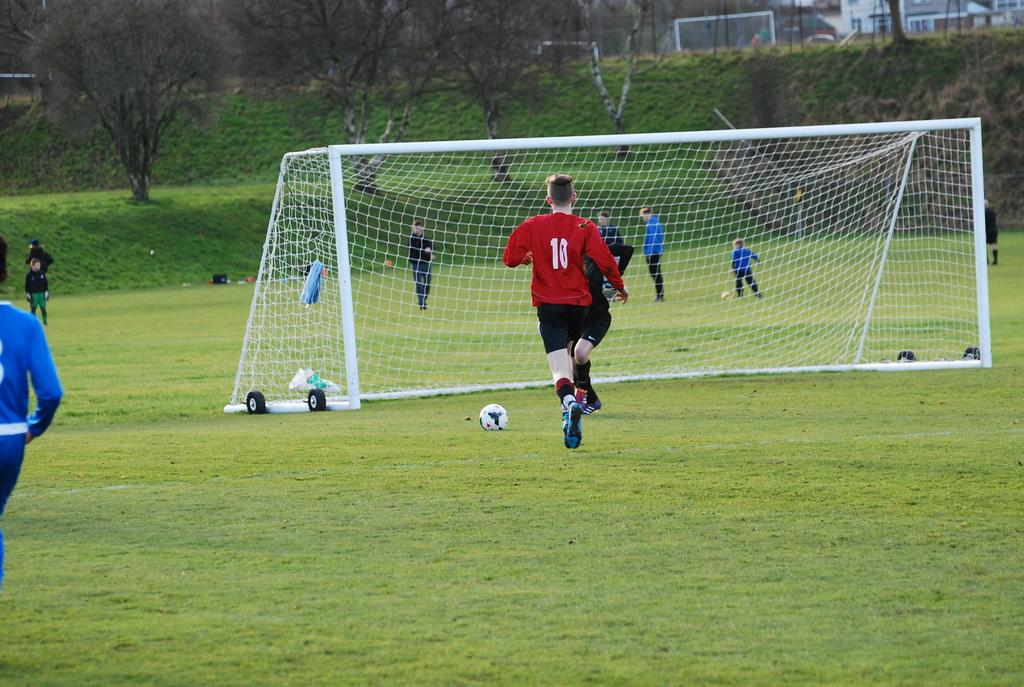<image>
Give a short and clear explanation of the subsequent image. A young boy in a red soccer shirt with the number 10 on the back running towards a placed ball in front of the goal. 